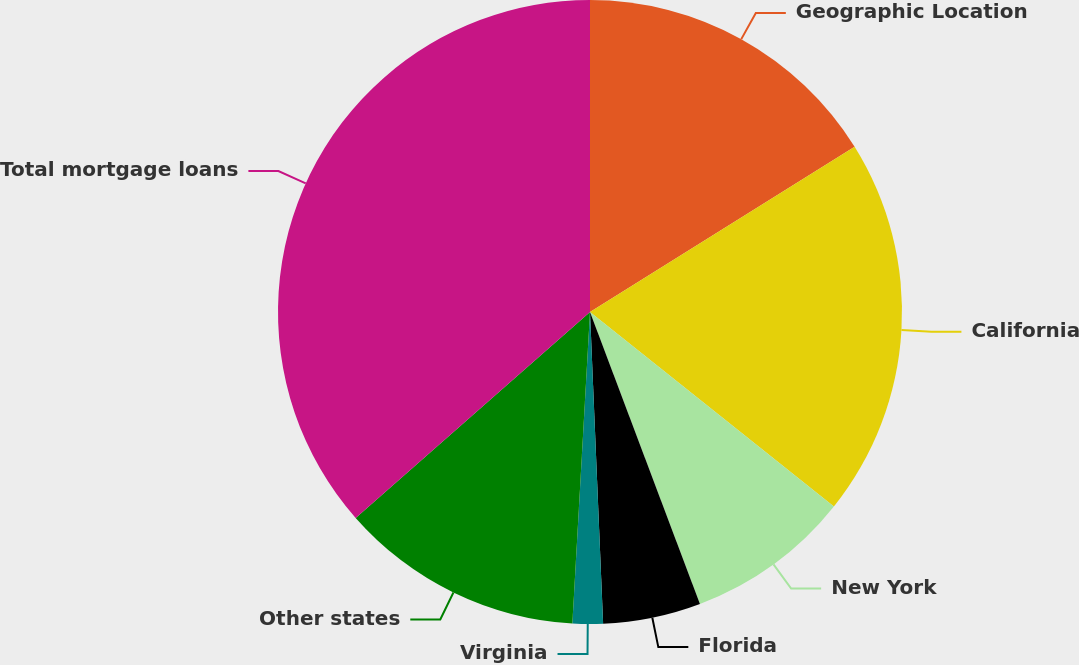<chart> <loc_0><loc_0><loc_500><loc_500><pie_chart><fcel>Geographic Location<fcel>California<fcel>New York<fcel>Florida<fcel>Virginia<fcel>Other states<fcel>Total mortgage loans<nl><fcel>16.11%<fcel>19.6%<fcel>8.55%<fcel>5.06%<fcel>1.57%<fcel>12.62%<fcel>36.47%<nl></chart> 